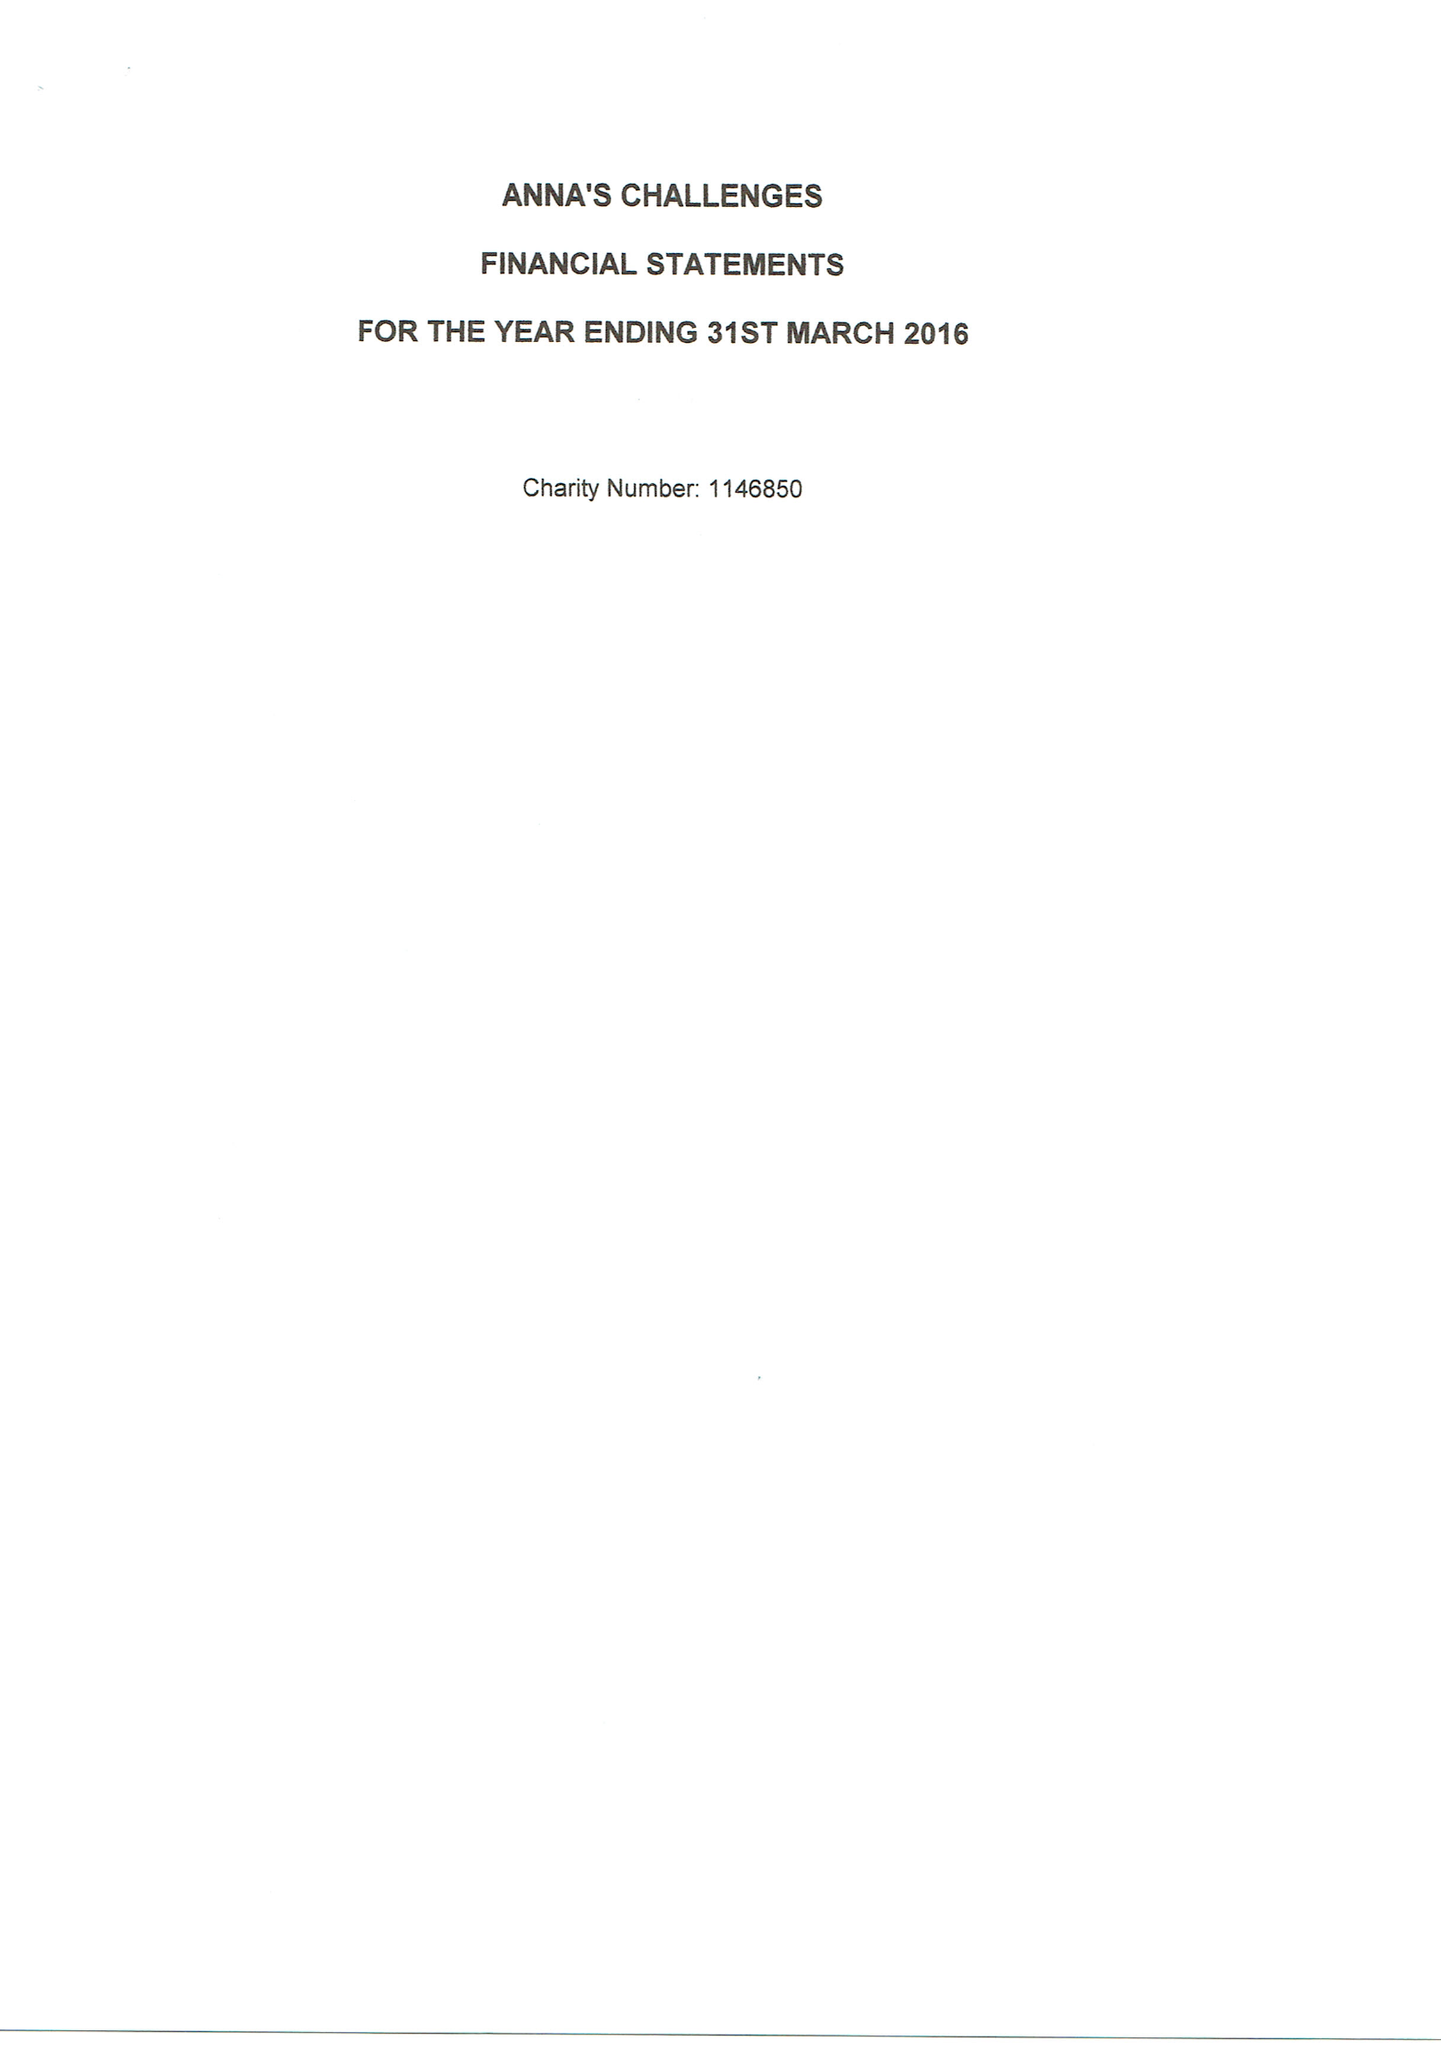What is the value for the report_date?
Answer the question using a single word or phrase. 2016-03-31 